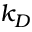Convert formula to latex. <formula><loc_0><loc_0><loc_500><loc_500>k _ { D }</formula> 